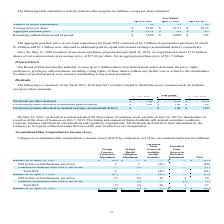From Netapp's financial document, Which years does the table provide information for number of shares repurchased under the company's stock repurchase program? The document contains multiple relevant values: 2019, 2018, 2017. From the document: "April 26, 2019 April 27, 2018 April 28, 2017 April 26, 2019 April 27, 2018 April 28, 2017 April 26, 2019 April 27, 2018 April 28, 2017..." Also, What did the company's Board of Directors authorize as of 2019? Based on the financial document, the answer is the repurchase of up to $13.6 billion of our common stock under our stock repurchase program. Also, What was the Aggregate purchase price in 2018? According to the financial document, 794 (in millions). The relevant text states: "Aggregate purchase price $ 2,111 $ 794 $ 705..." Also, can you calculate: What was the change in the Aggregate purchase price between 2018 and 2019? Based on the calculation: 2,111-794, the result is 1317 (in millions). This is based on the information: "Aggregate purchase price $ 2,111 $ 794 $ 705 Aggregate purchase price $ 2,111 $ 794 $ 705..." The key data points involved are: 2,111, 794. Also, can you calculate: What was the change in the average price per share between 2017 and 2018? Based on the calculation: 51.57-32.72, the result is 18.85. This is based on the information: "Average price per share $ 72.87 $ 51.57 $ 32.72 Average price per share $ 72.87 $ 51.57 $ 32.72..." The key data points involved are: 32.72, 51.57. Also, can you calculate: What was the percentage change in the Remaining authorization at end of period between 2018 and 2019? To answer this question, I need to perform calculations using the financial data. The calculation is: (1,889-4,000)/4,000, which equals -52.78 (percentage). This is based on the information: "Remaining authorization at end of period $ 1,889 $ 4,000 $ 794 emaining authorization at end of period $ 1,889 $ 4,000 $ 794..." The key data points involved are: 1,889, 4,000. 